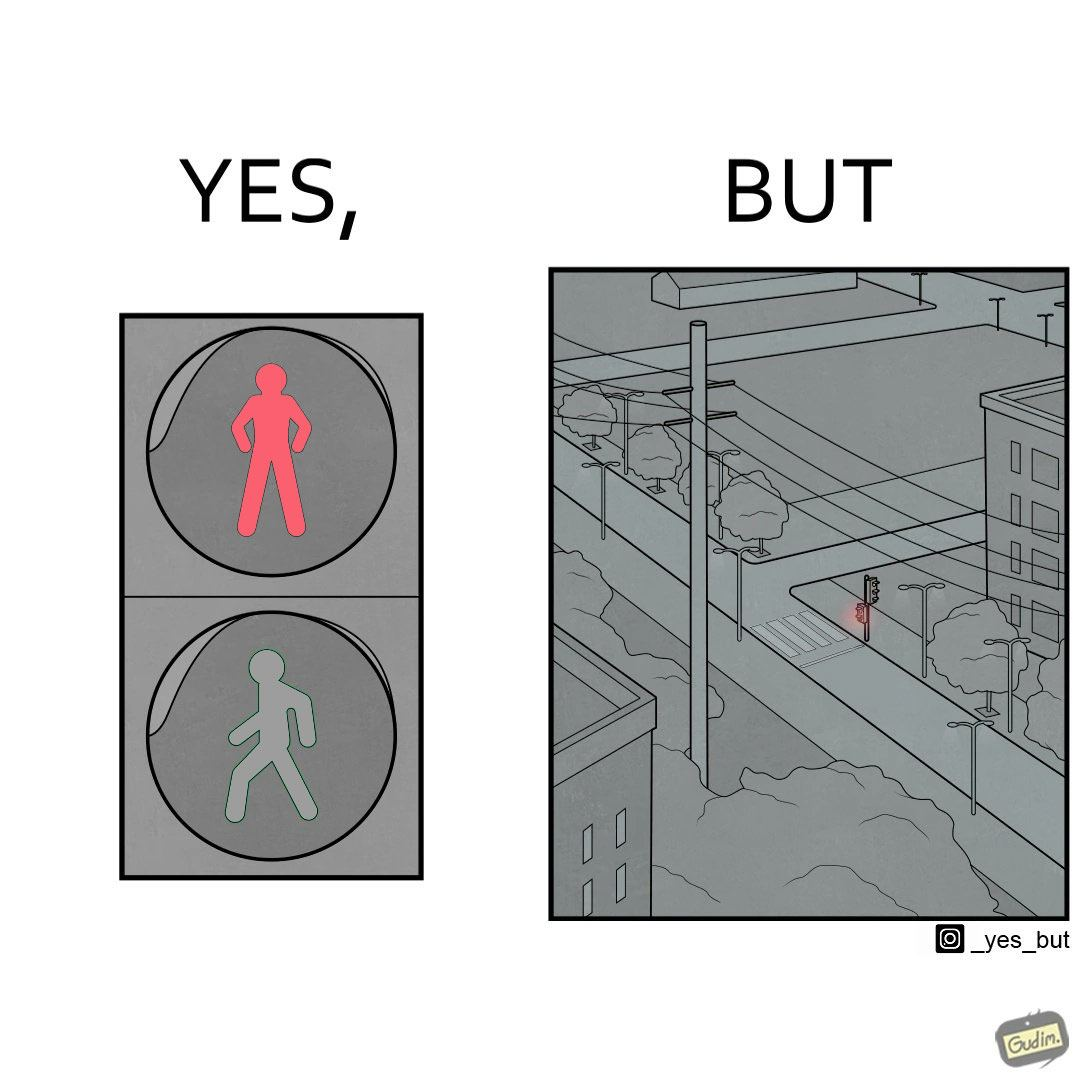What does this image depict? The image is funny, as the traffic light for pedestrains is red, even though it is at a zebra crossing, which does not need a red light for stopping a pedestrain from crossing. Also, there are no people or vehicles around, which makes the image even funnier. 